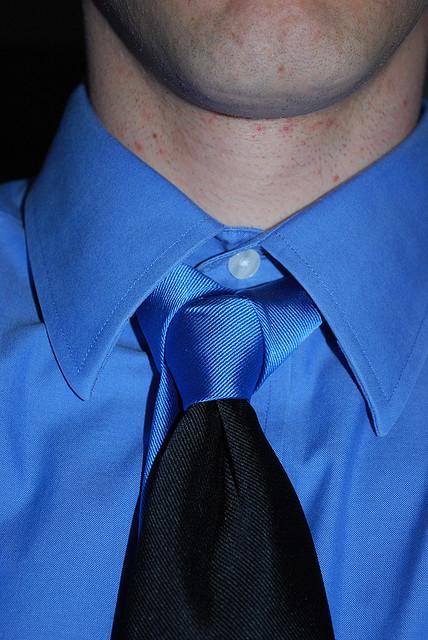Is the man clean-shaven or bearded?
Short answer required. Clean-shaven. What color is this man's tie?
Answer briefly. Black. Does the man have acne?
Be succinct. Yes. What is the color of the man's shirt?
Write a very short answer. Blue. 